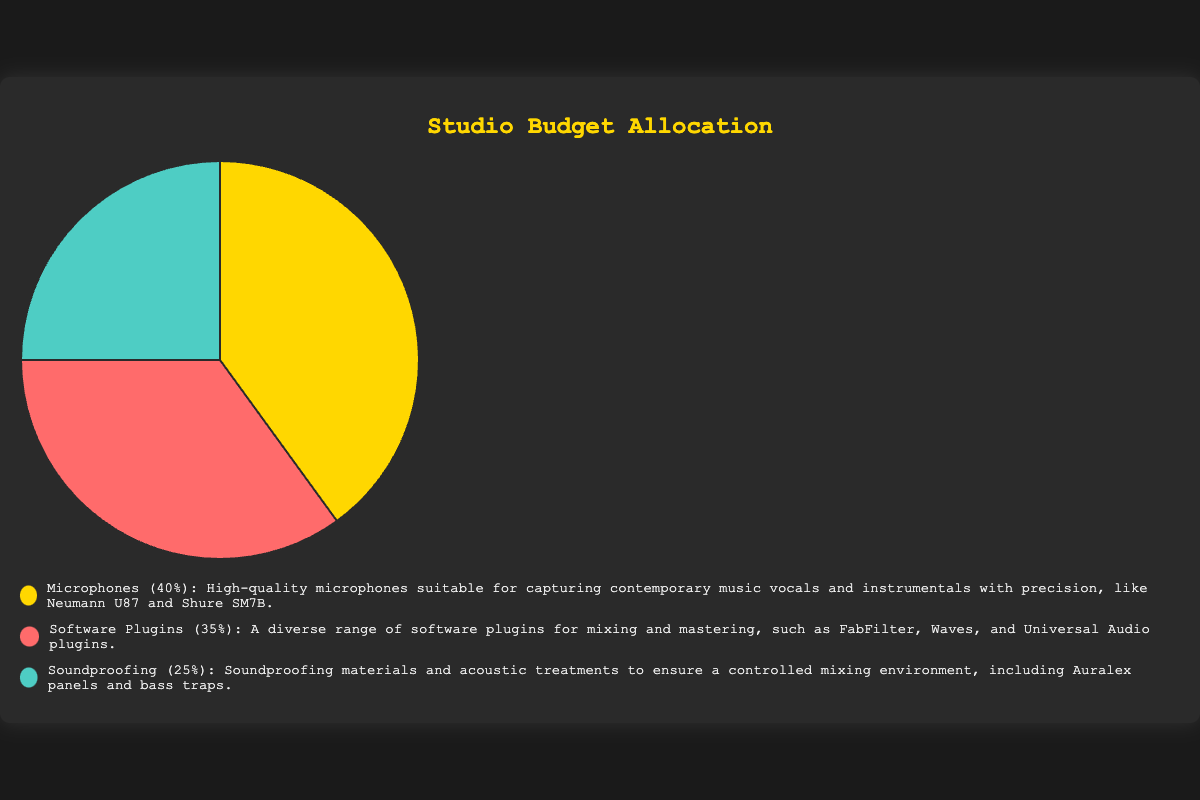What's the category with the largest budget allocation? The category with the largest budget allocation can be determined by looking at the pie chart segment that covers the biggest area. According to the chart, the "Microphones" category covers 40% of the total studio budget.
Answer: Microphones What percentage of the budget is allocated to software plugins? To find the percentage of the budget allocated to software plugins, you can refer to the chart and locate the slice labeled "Software Plugins." The chart shows that this category is allocated 35% of the budget.
Answer: 35% How does the budget for soundproofing compare to that for microphones? To compare the budgets, look at the percentages for "Soundproofing" and "Microphones." Soundproofing has 25% of the budget, while Microphones have 40%. Therefore, the budget for soundproofing is 15 percentage points less than that for microphones.
Answer: 15 percentage points less What is the combined budget percentage for software plugins and microphones? To find the combined budget percentage, add the percentages for "Software Plugins" and "Microphones." Software Plugins have 35%, and Microphones have 40%. 35% + 40% = 75%.
Answer: 75% What's the smallest budget allocation category? To identify the category with the smallest budget allocation, look for the smallest slice in the pie chart. The slice labeled "Soundproofing" represents 25% of the budget, which is the smallest among the three categories.
Answer: Soundproofing Which color represents the category for software plugins? To identify the color representing software plugins, refer to the chart's legend. The "Software Plugins" category is represented by the red segment in the pie chart.
Answer: Red If the budget for microphones was reduced by 10%, what would the new budget allocation be? The current budget for microphones is 40%. Reducing this by 10% involves calculating 10% of 40%, which is 4%. Subtracting 4% from 40% gives the new budget allocation: 40% - 4% = 36%.
Answer: 36% How much more budget is allocated to microphones compared to software plugins? To find the difference, subtract the percentage for software plugins from that for microphones. Microphones have 40%, and software plugins have 35%. 40% - 35% = 5%.
Answer: 5% What is the ratio of the budget for microphones to that of soundproofing? To find the ratio, compare the percentages for microphones and soundproofing. Microphones have 40% of the budget, and soundproofing has 25%. The ratio is 40% to 25%, which can be simplified to 8:5.
Answer: 8:5 If the budget for soundproofing was doubled, what percentage would it be? Currently, soundproofing takes up 25% of the budget. Doubling this budget allocation means multiplying 25% by 2, which results in 50%.
Answer: 50% 